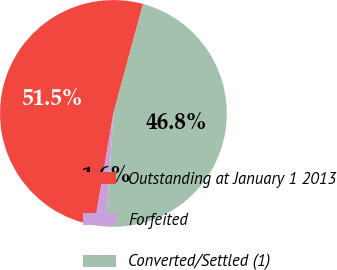Convert chart to OTSL. <chart><loc_0><loc_0><loc_500><loc_500><pie_chart><fcel>Outstanding at January 1 2013<fcel>Forfeited<fcel>Converted/Settled (1)<nl><fcel>51.53%<fcel>1.63%<fcel>46.84%<nl></chart> 